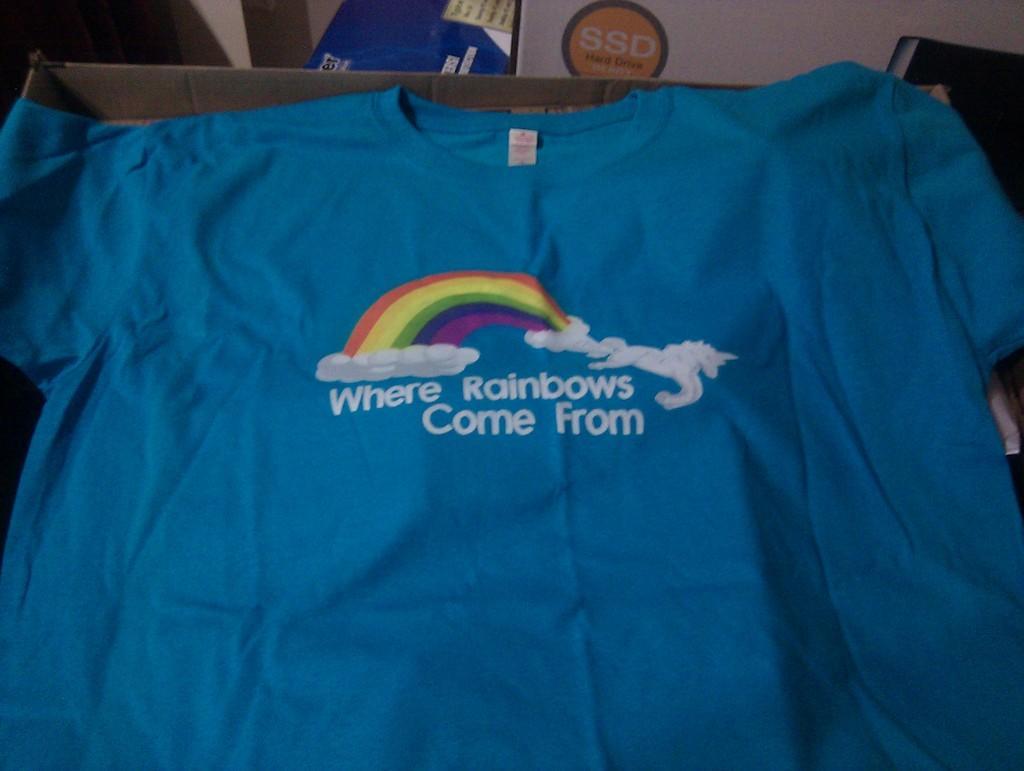Please provide a concise description of this image. In this picture we can see a t-shirt and in the background we can see some objects. 